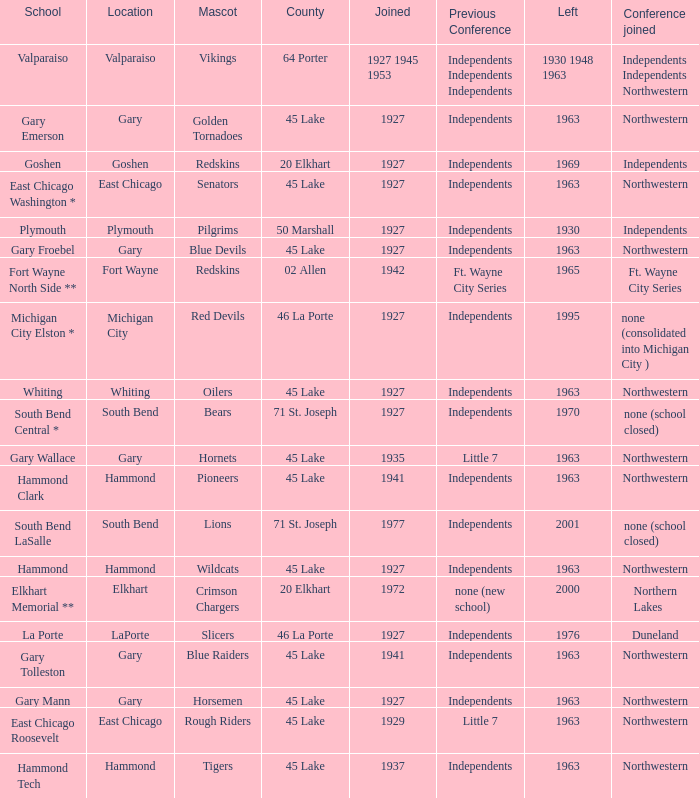When doeas Mascot of blue devils in Gary Froebel School? 1927.0. 